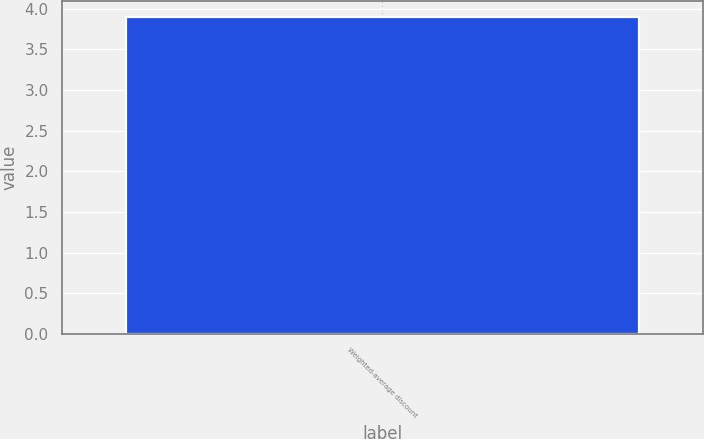Convert chart to OTSL. <chart><loc_0><loc_0><loc_500><loc_500><bar_chart><fcel>Weighted-average discount<nl><fcel>3.9<nl></chart> 